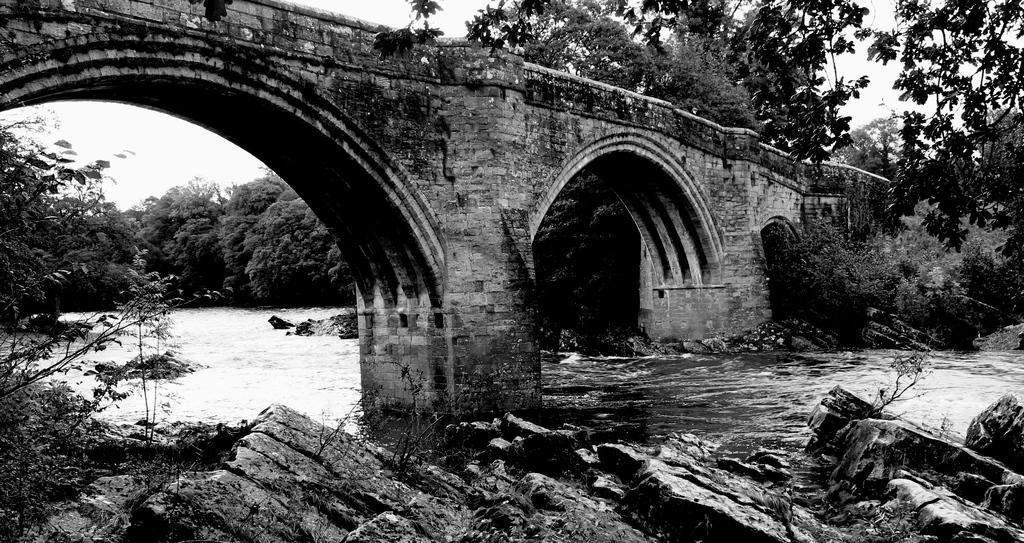What type of picture is in the image? The image contains a black and white picture. What is the main subject of the picture? The picture depicts a rocky surface. Are there any plants visible in the picture? Yes, there are trees in the picture. What can be seen in the water in the picture? The water is visible in the picture, but there is no specific detail about what is in the water. What structure is present in the picture? There is a bridge in the picture. What is visible in the background of the picture? The sky is visible in the background of the picture. How many grapes are hanging from the trees in the picture? There are no grapes visible in the picture; it depicts a rocky surface with trees and a bridge. Is there a baseball game taking place in the picture? There is no baseball game present in the picture; it features a rocky surface, trees, water, a bridge, and a sky. 